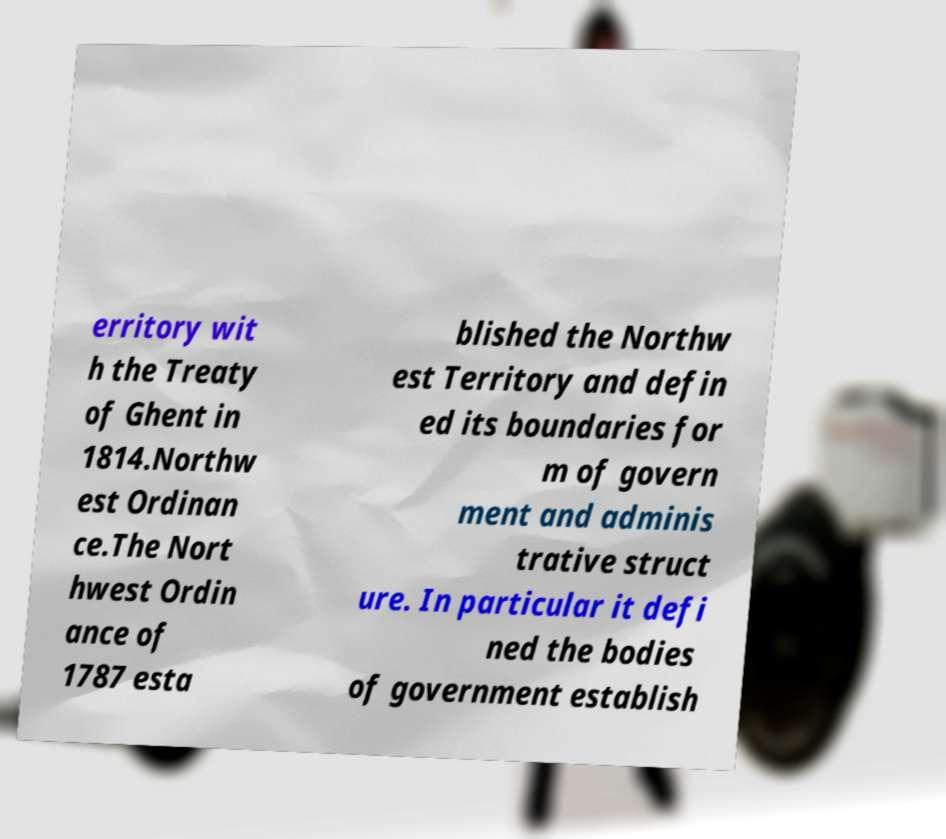Can you accurately transcribe the text from the provided image for me? erritory wit h the Treaty of Ghent in 1814.Northw est Ordinan ce.The Nort hwest Ordin ance of 1787 esta blished the Northw est Territory and defin ed its boundaries for m of govern ment and adminis trative struct ure. In particular it defi ned the bodies of government establish 